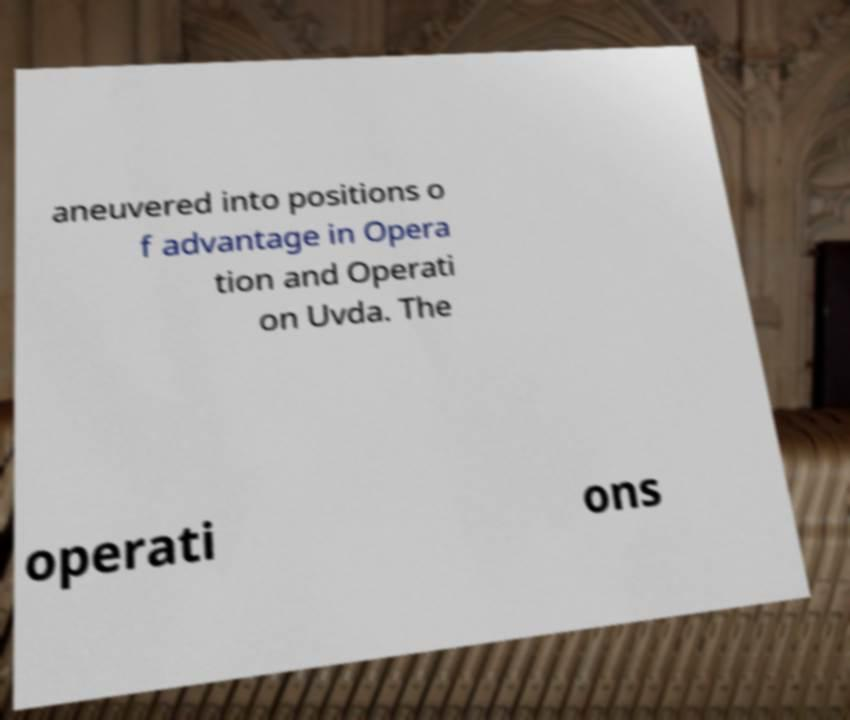Please read and relay the text visible in this image. What does it say? aneuvered into positions o f advantage in Opera tion and Operati on Uvda. The operati ons 